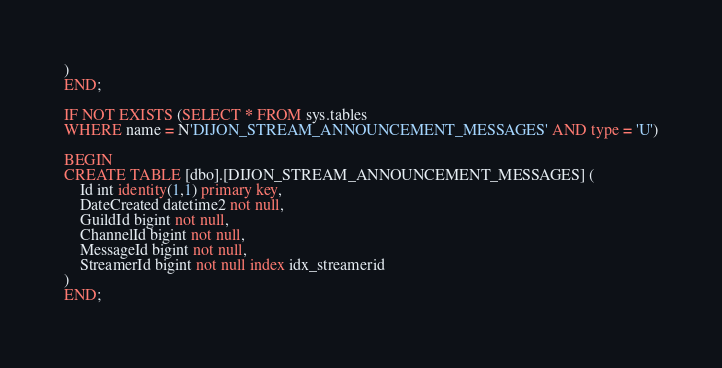<code> <loc_0><loc_0><loc_500><loc_500><_SQL_>)
END;

IF NOT EXISTS (SELECT * FROM sys.tables
WHERE name = N'DIJON_STREAM_ANNOUNCEMENT_MESSAGES' AND type = 'U')

BEGIN
CREATE TABLE [dbo].[DIJON_STREAM_ANNOUNCEMENT_MESSAGES] (
    Id int identity(1,1) primary key,
    DateCreated datetime2 not null,
    GuildId bigint not null,
    ChannelId bigint not null,
    MessageId bigint not null,
    StreamerId bigint not null index idx_streamerid
)
END;
</code> 